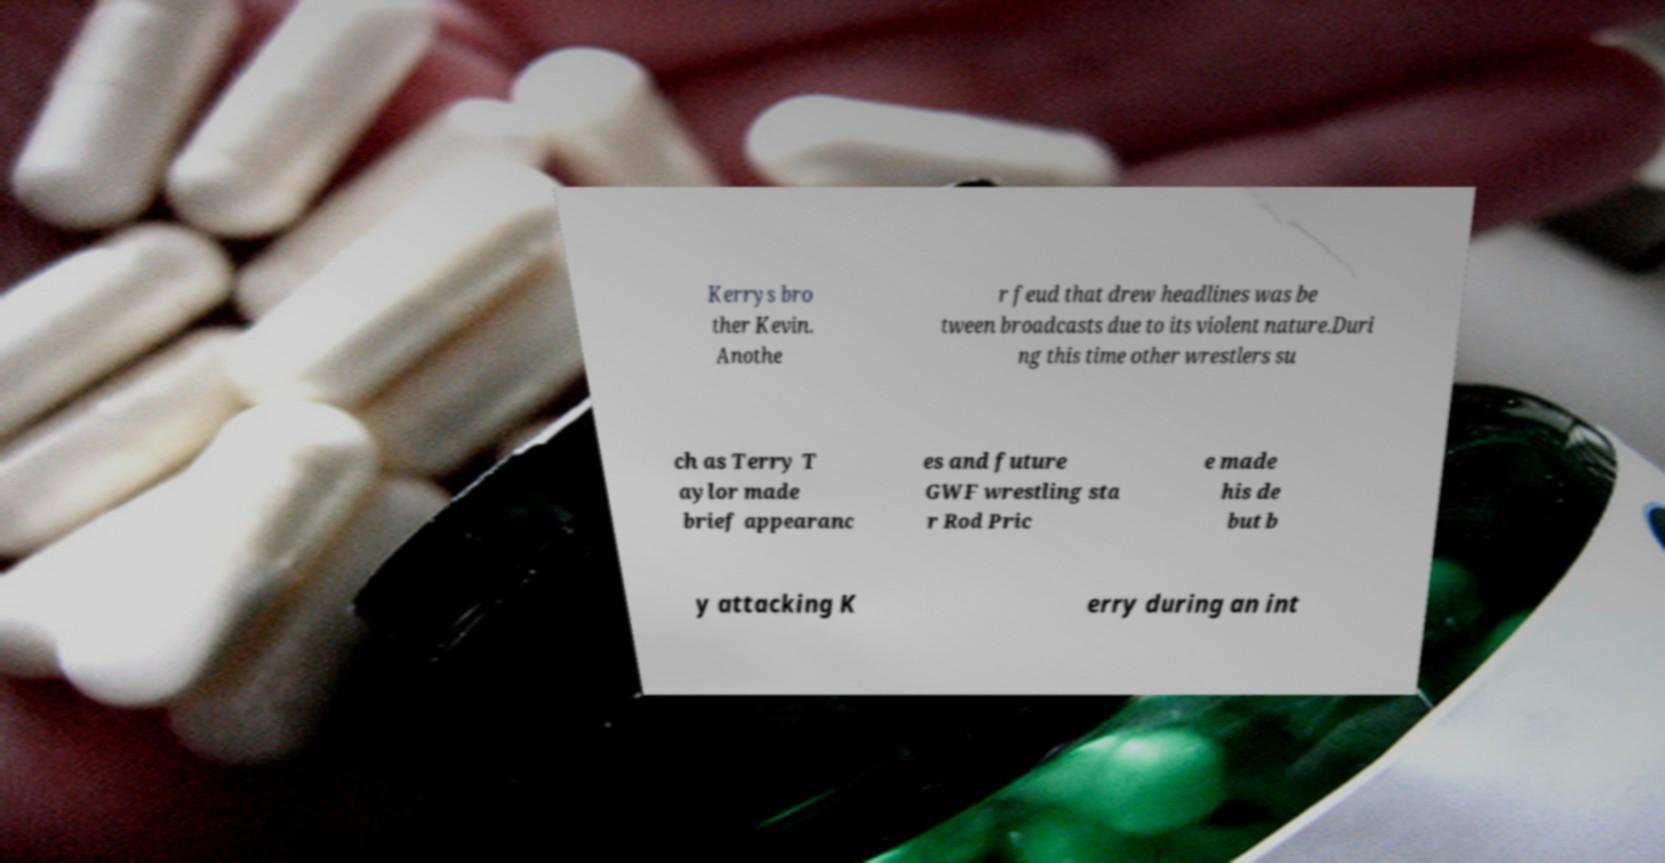Please read and relay the text visible in this image. What does it say? Kerrys bro ther Kevin. Anothe r feud that drew headlines was be tween broadcasts due to its violent nature.Duri ng this time other wrestlers su ch as Terry T aylor made brief appearanc es and future GWF wrestling sta r Rod Pric e made his de but b y attacking K erry during an int 